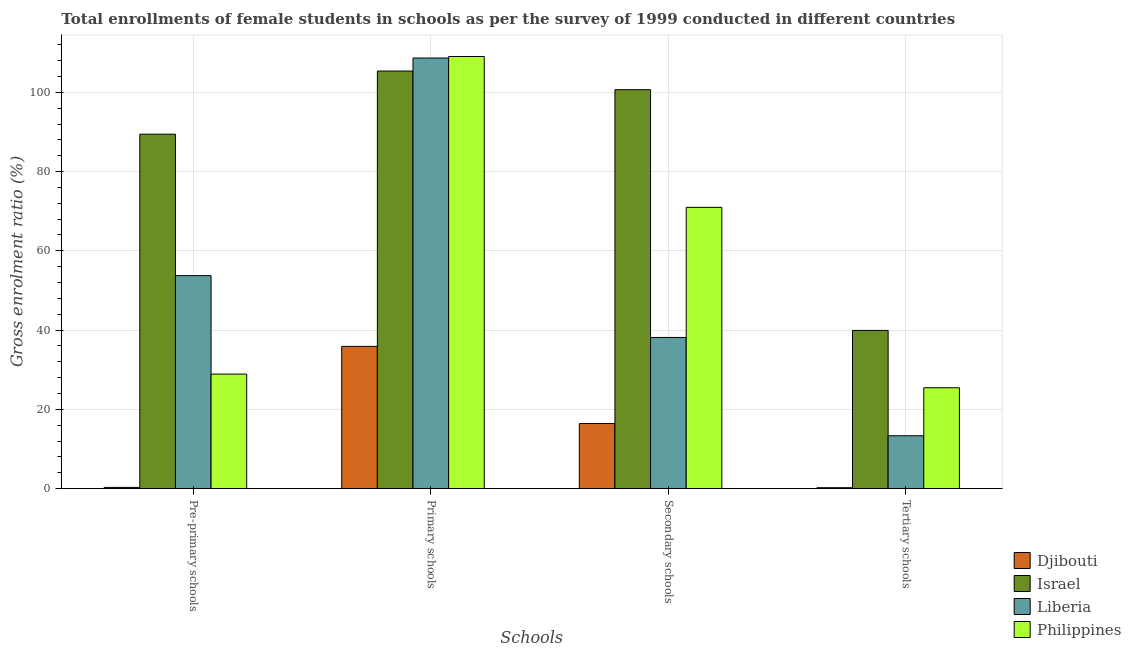How many different coloured bars are there?
Keep it short and to the point. 4. How many groups of bars are there?
Ensure brevity in your answer.  4. Are the number of bars per tick equal to the number of legend labels?
Offer a very short reply. Yes. Are the number of bars on each tick of the X-axis equal?
Make the answer very short. Yes. How many bars are there on the 3rd tick from the right?
Make the answer very short. 4. What is the label of the 2nd group of bars from the left?
Give a very brief answer. Primary schools. What is the gross enrolment ratio(female) in secondary schools in Philippines?
Offer a very short reply. 70.97. Across all countries, what is the maximum gross enrolment ratio(female) in primary schools?
Ensure brevity in your answer.  109.03. Across all countries, what is the minimum gross enrolment ratio(female) in pre-primary schools?
Ensure brevity in your answer.  0.32. In which country was the gross enrolment ratio(female) in pre-primary schools maximum?
Keep it short and to the point. Israel. In which country was the gross enrolment ratio(female) in pre-primary schools minimum?
Ensure brevity in your answer.  Djibouti. What is the total gross enrolment ratio(female) in tertiary schools in the graph?
Give a very brief answer. 78.98. What is the difference between the gross enrolment ratio(female) in secondary schools in Philippines and that in Djibouti?
Give a very brief answer. 54.54. What is the difference between the gross enrolment ratio(female) in secondary schools in Djibouti and the gross enrolment ratio(female) in pre-primary schools in Philippines?
Provide a short and direct response. -12.48. What is the average gross enrolment ratio(female) in secondary schools per country?
Give a very brief answer. 56.55. What is the difference between the gross enrolment ratio(female) in secondary schools and gross enrolment ratio(female) in tertiary schools in Israel?
Offer a very short reply. 60.74. What is the ratio of the gross enrolment ratio(female) in pre-primary schools in Liberia to that in Djibouti?
Offer a very short reply. 166.32. Is the gross enrolment ratio(female) in primary schools in Israel less than that in Philippines?
Offer a very short reply. Yes. What is the difference between the highest and the second highest gross enrolment ratio(female) in secondary schools?
Offer a very short reply. 29.69. What is the difference between the highest and the lowest gross enrolment ratio(female) in secondary schools?
Your answer should be very brief. 84.23. What does the 3rd bar from the left in Tertiary schools represents?
Offer a terse response. Liberia. Is it the case that in every country, the sum of the gross enrolment ratio(female) in pre-primary schools and gross enrolment ratio(female) in primary schools is greater than the gross enrolment ratio(female) in secondary schools?
Keep it short and to the point. Yes. How many bars are there?
Your response must be concise. 16. Does the graph contain any zero values?
Provide a succinct answer. No. Where does the legend appear in the graph?
Give a very brief answer. Bottom right. What is the title of the graph?
Your answer should be compact. Total enrollments of female students in schools as per the survey of 1999 conducted in different countries. Does "Cameroon" appear as one of the legend labels in the graph?
Offer a terse response. No. What is the label or title of the X-axis?
Your response must be concise. Schools. What is the label or title of the Y-axis?
Your answer should be very brief. Gross enrolment ratio (%). What is the Gross enrolment ratio (%) of Djibouti in Pre-primary schools?
Provide a short and direct response. 0.32. What is the Gross enrolment ratio (%) in Israel in Pre-primary schools?
Offer a very short reply. 89.43. What is the Gross enrolment ratio (%) of Liberia in Pre-primary schools?
Ensure brevity in your answer.  53.74. What is the Gross enrolment ratio (%) in Philippines in Pre-primary schools?
Offer a very short reply. 28.91. What is the Gross enrolment ratio (%) in Djibouti in Primary schools?
Ensure brevity in your answer.  35.9. What is the Gross enrolment ratio (%) in Israel in Primary schools?
Your answer should be compact. 105.36. What is the Gross enrolment ratio (%) in Liberia in Primary schools?
Provide a succinct answer. 108.65. What is the Gross enrolment ratio (%) in Philippines in Primary schools?
Ensure brevity in your answer.  109.03. What is the Gross enrolment ratio (%) of Djibouti in Secondary schools?
Offer a very short reply. 16.43. What is the Gross enrolment ratio (%) in Israel in Secondary schools?
Offer a very short reply. 100.66. What is the Gross enrolment ratio (%) in Liberia in Secondary schools?
Make the answer very short. 38.15. What is the Gross enrolment ratio (%) of Philippines in Secondary schools?
Your response must be concise. 70.97. What is the Gross enrolment ratio (%) of Djibouti in Tertiary schools?
Make the answer very short. 0.25. What is the Gross enrolment ratio (%) of Israel in Tertiary schools?
Your response must be concise. 39.92. What is the Gross enrolment ratio (%) of Liberia in Tertiary schools?
Keep it short and to the point. 13.35. What is the Gross enrolment ratio (%) of Philippines in Tertiary schools?
Make the answer very short. 25.47. Across all Schools, what is the maximum Gross enrolment ratio (%) of Djibouti?
Offer a very short reply. 35.9. Across all Schools, what is the maximum Gross enrolment ratio (%) in Israel?
Your answer should be compact. 105.36. Across all Schools, what is the maximum Gross enrolment ratio (%) in Liberia?
Offer a very short reply. 108.65. Across all Schools, what is the maximum Gross enrolment ratio (%) in Philippines?
Offer a terse response. 109.03. Across all Schools, what is the minimum Gross enrolment ratio (%) in Djibouti?
Provide a short and direct response. 0.25. Across all Schools, what is the minimum Gross enrolment ratio (%) in Israel?
Your answer should be compact. 39.92. Across all Schools, what is the minimum Gross enrolment ratio (%) of Liberia?
Keep it short and to the point. 13.35. Across all Schools, what is the minimum Gross enrolment ratio (%) in Philippines?
Make the answer very short. 25.47. What is the total Gross enrolment ratio (%) in Djibouti in the graph?
Provide a succinct answer. 52.9. What is the total Gross enrolment ratio (%) in Israel in the graph?
Keep it short and to the point. 335.38. What is the total Gross enrolment ratio (%) in Liberia in the graph?
Offer a very short reply. 213.89. What is the total Gross enrolment ratio (%) in Philippines in the graph?
Make the answer very short. 234.38. What is the difference between the Gross enrolment ratio (%) in Djibouti in Pre-primary schools and that in Primary schools?
Ensure brevity in your answer.  -35.58. What is the difference between the Gross enrolment ratio (%) of Israel in Pre-primary schools and that in Primary schools?
Ensure brevity in your answer.  -15.93. What is the difference between the Gross enrolment ratio (%) of Liberia in Pre-primary schools and that in Primary schools?
Offer a very short reply. -54.91. What is the difference between the Gross enrolment ratio (%) of Philippines in Pre-primary schools and that in Primary schools?
Your answer should be very brief. -80.13. What is the difference between the Gross enrolment ratio (%) in Djibouti in Pre-primary schools and that in Secondary schools?
Make the answer very short. -16.11. What is the difference between the Gross enrolment ratio (%) of Israel in Pre-primary schools and that in Secondary schools?
Provide a succinct answer. -11.23. What is the difference between the Gross enrolment ratio (%) of Liberia in Pre-primary schools and that in Secondary schools?
Make the answer very short. 15.59. What is the difference between the Gross enrolment ratio (%) of Philippines in Pre-primary schools and that in Secondary schools?
Provide a succinct answer. -42.07. What is the difference between the Gross enrolment ratio (%) in Djibouti in Pre-primary schools and that in Tertiary schools?
Your answer should be very brief. 0.08. What is the difference between the Gross enrolment ratio (%) in Israel in Pre-primary schools and that in Tertiary schools?
Keep it short and to the point. 49.51. What is the difference between the Gross enrolment ratio (%) in Liberia in Pre-primary schools and that in Tertiary schools?
Offer a very short reply. 40.39. What is the difference between the Gross enrolment ratio (%) in Philippines in Pre-primary schools and that in Tertiary schools?
Keep it short and to the point. 3.44. What is the difference between the Gross enrolment ratio (%) in Djibouti in Primary schools and that in Secondary schools?
Keep it short and to the point. 19.47. What is the difference between the Gross enrolment ratio (%) in Israel in Primary schools and that in Secondary schools?
Offer a very short reply. 4.7. What is the difference between the Gross enrolment ratio (%) in Liberia in Primary schools and that in Secondary schools?
Make the answer very short. 70.5. What is the difference between the Gross enrolment ratio (%) in Philippines in Primary schools and that in Secondary schools?
Provide a short and direct response. 38.06. What is the difference between the Gross enrolment ratio (%) of Djibouti in Primary schools and that in Tertiary schools?
Your response must be concise. 35.66. What is the difference between the Gross enrolment ratio (%) of Israel in Primary schools and that in Tertiary schools?
Ensure brevity in your answer.  65.44. What is the difference between the Gross enrolment ratio (%) in Liberia in Primary schools and that in Tertiary schools?
Your answer should be compact. 95.3. What is the difference between the Gross enrolment ratio (%) of Philippines in Primary schools and that in Tertiary schools?
Your response must be concise. 83.57. What is the difference between the Gross enrolment ratio (%) of Djibouti in Secondary schools and that in Tertiary schools?
Your response must be concise. 16.19. What is the difference between the Gross enrolment ratio (%) in Israel in Secondary schools and that in Tertiary schools?
Keep it short and to the point. 60.74. What is the difference between the Gross enrolment ratio (%) of Liberia in Secondary schools and that in Tertiary schools?
Your response must be concise. 24.8. What is the difference between the Gross enrolment ratio (%) in Philippines in Secondary schools and that in Tertiary schools?
Offer a very short reply. 45.51. What is the difference between the Gross enrolment ratio (%) of Djibouti in Pre-primary schools and the Gross enrolment ratio (%) of Israel in Primary schools?
Provide a succinct answer. -105.04. What is the difference between the Gross enrolment ratio (%) of Djibouti in Pre-primary schools and the Gross enrolment ratio (%) of Liberia in Primary schools?
Your answer should be very brief. -108.33. What is the difference between the Gross enrolment ratio (%) in Djibouti in Pre-primary schools and the Gross enrolment ratio (%) in Philippines in Primary schools?
Make the answer very short. -108.71. What is the difference between the Gross enrolment ratio (%) of Israel in Pre-primary schools and the Gross enrolment ratio (%) of Liberia in Primary schools?
Provide a short and direct response. -19.22. What is the difference between the Gross enrolment ratio (%) in Israel in Pre-primary schools and the Gross enrolment ratio (%) in Philippines in Primary schools?
Give a very brief answer. -19.6. What is the difference between the Gross enrolment ratio (%) in Liberia in Pre-primary schools and the Gross enrolment ratio (%) in Philippines in Primary schools?
Offer a very short reply. -55.29. What is the difference between the Gross enrolment ratio (%) in Djibouti in Pre-primary schools and the Gross enrolment ratio (%) in Israel in Secondary schools?
Make the answer very short. -100.34. What is the difference between the Gross enrolment ratio (%) of Djibouti in Pre-primary schools and the Gross enrolment ratio (%) of Liberia in Secondary schools?
Ensure brevity in your answer.  -37.83. What is the difference between the Gross enrolment ratio (%) of Djibouti in Pre-primary schools and the Gross enrolment ratio (%) of Philippines in Secondary schools?
Provide a succinct answer. -70.65. What is the difference between the Gross enrolment ratio (%) in Israel in Pre-primary schools and the Gross enrolment ratio (%) in Liberia in Secondary schools?
Provide a succinct answer. 51.28. What is the difference between the Gross enrolment ratio (%) in Israel in Pre-primary schools and the Gross enrolment ratio (%) in Philippines in Secondary schools?
Your answer should be very brief. 18.46. What is the difference between the Gross enrolment ratio (%) in Liberia in Pre-primary schools and the Gross enrolment ratio (%) in Philippines in Secondary schools?
Ensure brevity in your answer.  -17.23. What is the difference between the Gross enrolment ratio (%) in Djibouti in Pre-primary schools and the Gross enrolment ratio (%) in Israel in Tertiary schools?
Provide a short and direct response. -39.6. What is the difference between the Gross enrolment ratio (%) in Djibouti in Pre-primary schools and the Gross enrolment ratio (%) in Liberia in Tertiary schools?
Ensure brevity in your answer.  -13.03. What is the difference between the Gross enrolment ratio (%) of Djibouti in Pre-primary schools and the Gross enrolment ratio (%) of Philippines in Tertiary schools?
Offer a terse response. -25.14. What is the difference between the Gross enrolment ratio (%) in Israel in Pre-primary schools and the Gross enrolment ratio (%) in Liberia in Tertiary schools?
Your answer should be compact. 76.08. What is the difference between the Gross enrolment ratio (%) of Israel in Pre-primary schools and the Gross enrolment ratio (%) of Philippines in Tertiary schools?
Provide a succinct answer. 63.97. What is the difference between the Gross enrolment ratio (%) of Liberia in Pre-primary schools and the Gross enrolment ratio (%) of Philippines in Tertiary schools?
Your answer should be compact. 28.28. What is the difference between the Gross enrolment ratio (%) in Djibouti in Primary schools and the Gross enrolment ratio (%) in Israel in Secondary schools?
Give a very brief answer. -64.76. What is the difference between the Gross enrolment ratio (%) of Djibouti in Primary schools and the Gross enrolment ratio (%) of Liberia in Secondary schools?
Ensure brevity in your answer.  -2.25. What is the difference between the Gross enrolment ratio (%) in Djibouti in Primary schools and the Gross enrolment ratio (%) in Philippines in Secondary schools?
Keep it short and to the point. -35.07. What is the difference between the Gross enrolment ratio (%) of Israel in Primary schools and the Gross enrolment ratio (%) of Liberia in Secondary schools?
Offer a very short reply. 67.21. What is the difference between the Gross enrolment ratio (%) in Israel in Primary schools and the Gross enrolment ratio (%) in Philippines in Secondary schools?
Give a very brief answer. 34.39. What is the difference between the Gross enrolment ratio (%) in Liberia in Primary schools and the Gross enrolment ratio (%) in Philippines in Secondary schools?
Offer a very short reply. 37.68. What is the difference between the Gross enrolment ratio (%) of Djibouti in Primary schools and the Gross enrolment ratio (%) of Israel in Tertiary schools?
Ensure brevity in your answer.  -4.02. What is the difference between the Gross enrolment ratio (%) in Djibouti in Primary schools and the Gross enrolment ratio (%) in Liberia in Tertiary schools?
Your response must be concise. 22.55. What is the difference between the Gross enrolment ratio (%) in Djibouti in Primary schools and the Gross enrolment ratio (%) in Philippines in Tertiary schools?
Give a very brief answer. 10.44. What is the difference between the Gross enrolment ratio (%) of Israel in Primary schools and the Gross enrolment ratio (%) of Liberia in Tertiary schools?
Offer a terse response. 92.01. What is the difference between the Gross enrolment ratio (%) of Israel in Primary schools and the Gross enrolment ratio (%) of Philippines in Tertiary schools?
Ensure brevity in your answer.  79.9. What is the difference between the Gross enrolment ratio (%) in Liberia in Primary schools and the Gross enrolment ratio (%) in Philippines in Tertiary schools?
Offer a terse response. 83.18. What is the difference between the Gross enrolment ratio (%) in Djibouti in Secondary schools and the Gross enrolment ratio (%) in Israel in Tertiary schools?
Your response must be concise. -23.49. What is the difference between the Gross enrolment ratio (%) in Djibouti in Secondary schools and the Gross enrolment ratio (%) in Liberia in Tertiary schools?
Make the answer very short. 3.08. What is the difference between the Gross enrolment ratio (%) in Djibouti in Secondary schools and the Gross enrolment ratio (%) in Philippines in Tertiary schools?
Provide a succinct answer. -9.03. What is the difference between the Gross enrolment ratio (%) of Israel in Secondary schools and the Gross enrolment ratio (%) of Liberia in Tertiary schools?
Give a very brief answer. 87.31. What is the difference between the Gross enrolment ratio (%) in Israel in Secondary schools and the Gross enrolment ratio (%) in Philippines in Tertiary schools?
Offer a very short reply. 75.19. What is the difference between the Gross enrolment ratio (%) in Liberia in Secondary schools and the Gross enrolment ratio (%) in Philippines in Tertiary schools?
Make the answer very short. 12.68. What is the average Gross enrolment ratio (%) of Djibouti per Schools?
Give a very brief answer. 13.23. What is the average Gross enrolment ratio (%) in Israel per Schools?
Offer a very short reply. 83.84. What is the average Gross enrolment ratio (%) in Liberia per Schools?
Provide a succinct answer. 53.47. What is the average Gross enrolment ratio (%) of Philippines per Schools?
Offer a terse response. 58.6. What is the difference between the Gross enrolment ratio (%) of Djibouti and Gross enrolment ratio (%) of Israel in Pre-primary schools?
Ensure brevity in your answer.  -89.11. What is the difference between the Gross enrolment ratio (%) of Djibouti and Gross enrolment ratio (%) of Liberia in Pre-primary schools?
Your answer should be very brief. -53.42. What is the difference between the Gross enrolment ratio (%) in Djibouti and Gross enrolment ratio (%) in Philippines in Pre-primary schools?
Provide a succinct answer. -28.58. What is the difference between the Gross enrolment ratio (%) of Israel and Gross enrolment ratio (%) of Liberia in Pre-primary schools?
Your response must be concise. 35.69. What is the difference between the Gross enrolment ratio (%) of Israel and Gross enrolment ratio (%) of Philippines in Pre-primary schools?
Your response must be concise. 60.52. What is the difference between the Gross enrolment ratio (%) in Liberia and Gross enrolment ratio (%) in Philippines in Pre-primary schools?
Give a very brief answer. 24.83. What is the difference between the Gross enrolment ratio (%) of Djibouti and Gross enrolment ratio (%) of Israel in Primary schools?
Your answer should be compact. -69.46. What is the difference between the Gross enrolment ratio (%) of Djibouti and Gross enrolment ratio (%) of Liberia in Primary schools?
Keep it short and to the point. -72.75. What is the difference between the Gross enrolment ratio (%) of Djibouti and Gross enrolment ratio (%) of Philippines in Primary schools?
Keep it short and to the point. -73.13. What is the difference between the Gross enrolment ratio (%) of Israel and Gross enrolment ratio (%) of Liberia in Primary schools?
Your response must be concise. -3.29. What is the difference between the Gross enrolment ratio (%) of Israel and Gross enrolment ratio (%) of Philippines in Primary schools?
Provide a short and direct response. -3.67. What is the difference between the Gross enrolment ratio (%) in Liberia and Gross enrolment ratio (%) in Philippines in Primary schools?
Your response must be concise. -0.38. What is the difference between the Gross enrolment ratio (%) in Djibouti and Gross enrolment ratio (%) in Israel in Secondary schools?
Give a very brief answer. -84.23. What is the difference between the Gross enrolment ratio (%) in Djibouti and Gross enrolment ratio (%) in Liberia in Secondary schools?
Offer a terse response. -21.72. What is the difference between the Gross enrolment ratio (%) of Djibouti and Gross enrolment ratio (%) of Philippines in Secondary schools?
Provide a short and direct response. -54.54. What is the difference between the Gross enrolment ratio (%) of Israel and Gross enrolment ratio (%) of Liberia in Secondary schools?
Offer a very short reply. 62.51. What is the difference between the Gross enrolment ratio (%) in Israel and Gross enrolment ratio (%) in Philippines in Secondary schools?
Offer a terse response. 29.69. What is the difference between the Gross enrolment ratio (%) of Liberia and Gross enrolment ratio (%) of Philippines in Secondary schools?
Your answer should be very brief. -32.82. What is the difference between the Gross enrolment ratio (%) of Djibouti and Gross enrolment ratio (%) of Israel in Tertiary schools?
Provide a short and direct response. -39.68. What is the difference between the Gross enrolment ratio (%) in Djibouti and Gross enrolment ratio (%) in Liberia in Tertiary schools?
Offer a terse response. -13.1. What is the difference between the Gross enrolment ratio (%) of Djibouti and Gross enrolment ratio (%) of Philippines in Tertiary schools?
Your response must be concise. -25.22. What is the difference between the Gross enrolment ratio (%) in Israel and Gross enrolment ratio (%) in Liberia in Tertiary schools?
Offer a very short reply. 26.57. What is the difference between the Gross enrolment ratio (%) of Israel and Gross enrolment ratio (%) of Philippines in Tertiary schools?
Make the answer very short. 14.46. What is the difference between the Gross enrolment ratio (%) in Liberia and Gross enrolment ratio (%) in Philippines in Tertiary schools?
Ensure brevity in your answer.  -12.12. What is the ratio of the Gross enrolment ratio (%) of Djibouti in Pre-primary schools to that in Primary schools?
Ensure brevity in your answer.  0.01. What is the ratio of the Gross enrolment ratio (%) in Israel in Pre-primary schools to that in Primary schools?
Make the answer very short. 0.85. What is the ratio of the Gross enrolment ratio (%) of Liberia in Pre-primary schools to that in Primary schools?
Provide a succinct answer. 0.49. What is the ratio of the Gross enrolment ratio (%) of Philippines in Pre-primary schools to that in Primary schools?
Give a very brief answer. 0.27. What is the ratio of the Gross enrolment ratio (%) of Djibouti in Pre-primary schools to that in Secondary schools?
Your response must be concise. 0.02. What is the ratio of the Gross enrolment ratio (%) of Israel in Pre-primary schools to that in Secondary schools?
Offer a terse response. 0.89. What is the ratio of the Gross enrolment ratio (%) of Liberia in Pre-primary schools to that in Secondary schools?
Make the answer very short. 1.41. What is the ratio of the Gross enrolment ratio (%) in Philippines in Pre-primary schools to that in Secondary schools?
Ensure brevity in your answer.  0.41. What is the ratio of the Gross enrolment ratio (%) in Djibouti in Pre-primary schools to that in Tertiary schools?
Keep it short and to the point. 1.32. What is the ratio of the Gross enrolment ratio (%) in Israel in Pre-primary schools to that in Tertiary schools?
Keep it short and to the point. 2.24. What is the ratio of the Gross enrolment ratio (%) in Liberia in Pre-primary schools to that in Tertiary schools?
Offer a very short reply. 4.03. What is the ratio of the Gross enrolment ratio (%) in Philippines in Pre-primary schools to that in Tertiary schools?
Ensure brevity in your answer.  1.14. What is the ratio of the Gross enrolment ratio (%) in Djibouti in Primary schools to that in Secondary schools?
Offer a very short reply. 2.18. What is the ratio of the Gross enrolment ratio (%) of Israel in Primary schools to that in Secondary schools?
Offer a very short reply. 1.05. What is the ratio of the Gross enrolment ratio (%) of Liberia in Primary schools to that in Secondary schools?
Keep it short and to the point. 2.85. What is the ratio of the Gross enrolment ratio (%) of Philippines in Primary schools to that in Secondary schools?
Your response must be concise. 1.54. What is the ratio of the Gross enrolment ratio (%) of Djibouti in Primary schools to that in Tertiary schools?
Give a very brief answer. 146.15. What is the ratio of the Gross enrolment ratio (%) of Israel in Primary schools to that in Tertiary schools?
Your answer should be very brief. 2.64. What is the ratio of the Gross enrolment ratio (%) of Liberia in Primary schools to that in Tertiary schools?
Your answer should be very brief. 8.14. What is the ratio of the Gross enrolment ratio (%) of Philippines in Primary schools to that in Tertiary schools?
Give a very brief answer. 4.28. What is the ratio of the Gross enrolment ratio (%) in Djibouti in Secondary schools to that in Tertiary schools?
Provide a short and direct response. 66.89. What is the ratio of the Gross enrolment ratio (%) in Israel in Secondary schools to that in Tertiary schools?
Make the answer very short. 2.52. What is the ratio of the Gross enrolment ratio (%) in Liberia in Secondary schools to that in Tertiary schools?
Your answer should be very brief. 2.86. What is the ratio of the Gross enrolment ratio (%) in Philippines in Secondary schools to that in Tertiary schools?
Provide a succinct answer. 2.79. What is the difference between the highest and the second highest Gross enrolment ratio (%) of Djibouti?
Ensure brevity in your answer.  19.47. What is the difference between the highest and the second highest Gross enrolment ratio (%) of Israel?
Offer a very short reply. 4.7. What is the difference between the highest and the second highest Gross enrolment ratio (%) in Liberia?
Give a very brief answer. 54.91. What is the difference between the highest and the second highest Gross enrolment ratio (%) in Philippines?
Provide a short and direct response. 38.06. What is the difference between the highest and the lowest Gross enrolment ratio (%) in Djibouti?
Your answer should be very brief. 35.66. What is the difference between the highest and the lowest Gross enrolment ratio (%) in Israel?
Provide a succinct answer. 65.44. What is the difference between the highest and the lowest Gross enrolment ratio (%) in Liberia?
Offer a terse response. 95.3. What is the difference between the highest and the lowest Gross enrolment ratio (%) in Philippines?
Offer a terse response. 83.57. 